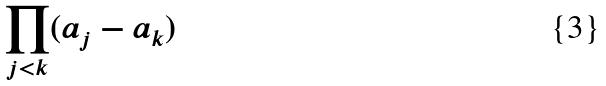Convert formula to latex. <formula><loc_0><loc_0><loc_500><loc_500>\prod _ { j < k } ( a _ { j } - a _ { k } )</formula> 